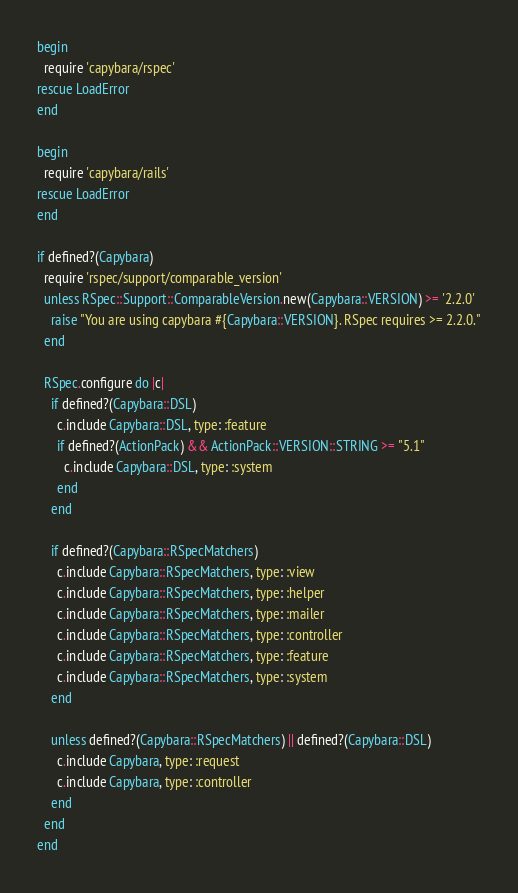<code> <loc_0><loc_0><loc_500><loc_500><_Ruby_>begin
  require 'capybara/rspec'
rescue LoadError
end

begin
  require 'capybara/rails'
rescue LoadError
end

if defined?(Capybara)
  require 'rspec/support/comparable_version'
  unless RSpec::Support::ComparableVersion.new(Capybara::VERSION) >= '2.2.0'
    raise "You are using capybara #{Capybara::VERSION}. RSpec requires >= 2.2.0."
  end

  RSpec.configure do |c|
    if defined?(Capybara::DSL)
      c.include Capybara::DSL, type: :feature
      if defined?(ActionPack) && ActionPack::VERSION::STRING >= "5.1"
        c.include Capybara::DSL, type: :system
      end
    end

    if defined?(Capybara::RSpecMatchers)
      c.include Capybara::RSpecMatchers, type: :view
      c.include Capybara::RSpecMatchers, type: :helper
      c.include Capybara::RSpecMatchers, type: :mailer
      c.include Capybara::RSpecMatchers, type: :controller
      c.include Capybara::RSpecMatchers, type: :feature
      c.include Capybara::RSpecMatchers, type: :system
    end

    unless defined?(Capybara::RSpecMatchers) || defined?(Capybara::DSL)
      c.include Capybara, type: :request
      c.include Capybara, type: :controller
    end
  end
end
</code> 